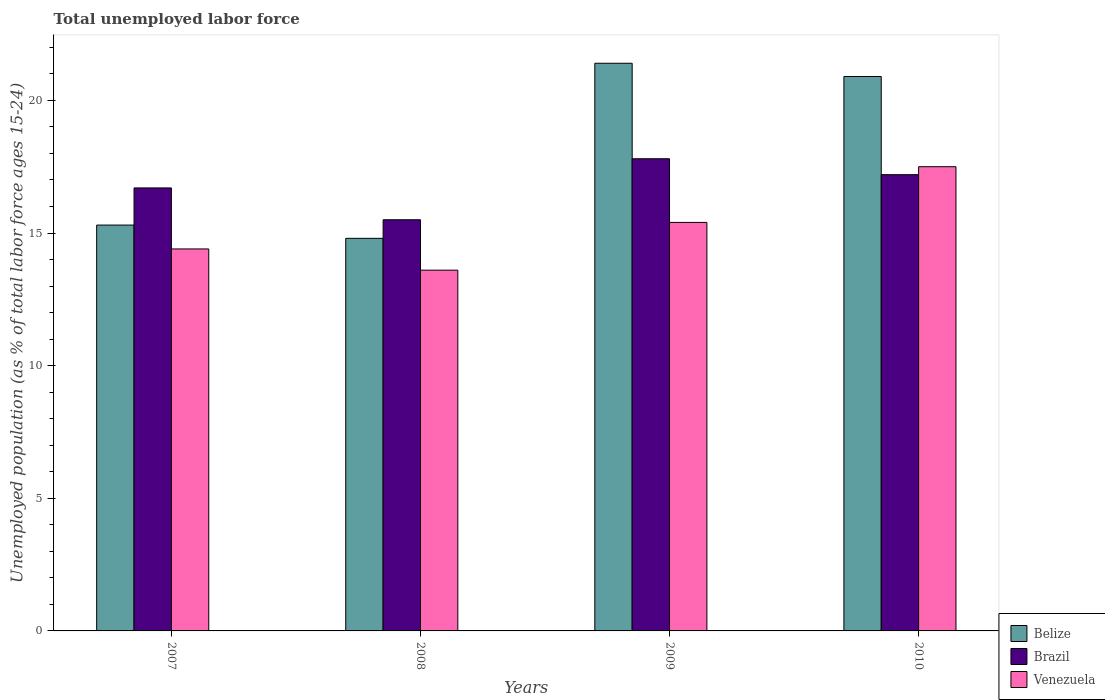How many different coloured bars are there?
Offer a very short reply. 3. How many groups of bars are there?
Give a very brief answer. 4. Are the number of bars on each tick of the X-axis equal?
Make the answer very short. Yes. How many bars are there on the 3rd tick from the right?
Your answer should be very brief. 3. In how many cases, is the number of bars for a given year not equal to the number of legend labels?
Your response must be concise. 0. What is the percentage of unemployed population in in Belize in 2008?
Your answer should be very brief. 14.8. Across all years, what is the maximum percentage of unemployed population in in Belize?
Give a very brief answer. 21.4. What is the total percentage of unemployed population in in Belize in the graph?
Make the answer very short. 72.4. What is the difference between the percentage of unemployed population in in Venezuela in 2007 and the percentage of unemployed population in in Belize in 2009?
Offer a very short reply. -7. What is the average percentage of unemployed population in in Belize per year?
Give a very brief answer. 18.1. In the year 2007, what is the difference between the percentage of unemployed population in in Brazil and percentage of unemployed population in in Venezuela?
Provide a succinct answer. 2.3. In how many years, is the percentage of unemployed population in in Venezuela greater than 14 %?
Offer a terse response. 3. What is the ratio of the percentage of unemployed population in in Venezuela in 2007 to that in 2009?
Keep it short and to the point. 0.94. What is the difference between the highest and the lowest percentage of unemployed population in in Belize?
Provide a succinct answer. 6.6. In how many years, is the percentage of unemployed population in in Brazil greater than the average percentage of unemployed population in in Brazil taken over all years?
Offer a very short reply. 2. What does the 1st bar from the left in 2010 represents?
Offer a terse response. Belize. Is it the case that in every year, the sum of the percentage of unemployed population in in Belize and percentage of unemployed population in in Venezuela is greater than the percentage of unemployed population in in Brazil?
Ensure brevity in your answer.  Yes. What is the difference between two consecutive major ticks on the Y-axis?
Ensure brevity in your answer.  5. Are the values on the major ticks of Y-axis written in scientific E-notation?
Offer a terse response. No. Does the graph contain any zero values?
Ensure brevity in your answer.  No. Where does the legend appear in the graph?
Make the answer very short. Bottom right. What is the title of the graph?
Your answer should be compact. Total unemployed labor force. What is the label or title of the X-axis?
Your response must be concise. Years. What is the label or title of the Y-axis?
Ensure brevity in your answer.  Unemployed population (as % of total labor force ages 15-24). What is the Unemployed population (as % of total labor force ages 15-24) in Belize in 2007?
Ensure brevity in your answer.  15.3. What is the Unemployed population (as % of total labor force ages 15-24) of Brazil in 2007?
Your answer should be compact. 16.7. What is the Unemployed population (as % of total labor force ages 15-24) in Venezuela in 2007?
Offer a terse response. 14.4. What is the Unemployed population (as % of total labor force ages 15-24) of Belize in 2008?
Give a very brief answer. 14.8. What is the Unemployed population (as % of total labor force ages 15-24) in Brazil in 2008?
Offer a terse response. 15.5. What is the Unemployed population (as % of total labor force ages 15-24) of Venezuela in 2008?
Ensure brevity in your answer.  13.6. What is the Unemployed population (as % of total labor force ages 15-24) in Belize in 2009?
Your answer should be compact. 21.4. What is the Unemployed population (as % of total labor force ages 15-24) of Brazil in 2009?
Give a very brief answer. 17.8. What is the Unemployed population (as % of total labor force ages 15-24) of Venezuela in 2009?
Give a very brief answer. 15.4. What is the Unemployed population (as % of total labor force ages 15-24) in Belize in 2010?
Your answer should be compact. 20.9. What is the Unemployed population (as % of total labor force ages 15-24) in Brazil in 2010?
Make the answer very short. 17.2. Across all years, what is the maximum Unemployed population (as % of total labor force ages 15-24) in Belize?
Your answer should be compact. 21.4. Across all years, what is the maximum Unemployed population (as % of total labor force ages 15-24) in Brazil?
Offer a terse response. 17.8. Across all years, what is the maximum Unemployed population (as % of total labor force ages 15-24) in Venezuela?
Offer a terse response. 17.5. Across all years, what is the minimum Unemployed population (as % of total labor force ages 15-24) in Belize?
Your response must be concise. 14.8. Across all years, what is the minimum Unemployed population (as % of total labor force ages 15-24) in Venezuela?
Offer a terse response. 13.6. What is the total Unemployed population (as % of total labor force ages 15-24) of Belize in the graph?
Ensure brevity in your answer.  72.4. What is the total Unemployed population (as % of total labor force ages 15-24) in Brazil in the graph?
Your response must be concise. 67.2. What is the total Unemployed population (as % of total labor force ages 15-24) in Venezuela in the graph?
Provide a short and direct response. 60.9. What is the difference between the Unemployed population (as % of total labor force ages 15-24) of Belize in 2007 and that in 2008?
Make the answer very short. 0.5. What is the difference between the Unemployed population (as % of total labor force ages 15-24) in Brazil in 2007 and that in 2008?
Offer a very short reply. 1.2. What is the difference between the Unemployed population (as % of total labor force ages 15-24) of Venezuela in 2007 and that in 2008?
Provide a short and direct response. 0.8. What is the difference between the Unemployed population (as % of total labor force ages 15-24) in Brazil in 2007 and that in 2009?
Make the answer very short. -1.1. What is the difference between the Unemployed population (as % of total labor force ages 15-24) of Brazil in 2007 and that in 2010?
Provide a succinct answer. -0.5. What is the difference between the Unemployed population (as % of total labor force ages 15-24) in Venezuela in 2008 and that in 2009?
Provide a succinct answer. -1.8. What is the difference between the Unemployed population (as % of total labor force ages 15-24) in Belize in 2009 and that in 2010?
Your response must be concise. 0.5. What is the difference between the Unemployed population (as % of total labor force ages 15-24) in Brazil in 2009 and that in 2010?
Keep it short and to the point. 0.6. What is the difference between the Unemployed population (as % of total labor force ages 15-24) of Brazil in 2007 and the Unemployed population (as % of total labor force ages 15-24) of Venezuela in 2008?
Your answer should be compact. 3.1. What is the difference between the Unemployed population (as % of total labor force ages 15-24) in Belize in 2007 and the Unemployed population (as % of total labor force ages 15-24) in Brazil in 2009?
Your answer should be compact. -2.5. What is the difference between the Unemployed population (as % of total labor force ages 15-24) in Belize in 2007 and the Unemployed population (as % of total labor force ages 15-24) in Venezuela in 2009?
Give a very brief answer. -0.1. What is the difference between the Unemployed population (as % of total labor force ages 15-24) of Brazil in 2007 and the Unemployed population (as % of total labor force ages 15-24) of Venezuela in 2009?
Make the answer very short. 1.3. What is the difference between the Unemployed population (as % of total labor force ages 15-24) in Belize in 2007 and the Unemployed population (as % of total labor force ages 15-24) in Brazil in 2010?
Your answer should be compact. -1.9. What is the difference between the Unemployed population (as % of total labor force ages 15-24) of Belize in 2007 and the Unemployed population (as % of total labor force ages 15-24) of Venezuela in 2010?
Your response must be concise. -2.2. What is the difference between the Unemployed population (as % of total labor force ages 15-24) of Belize in 2008 and the Unemployed population (as % of total labor force ages 15-24) of Brazil in 2009?
Keep it short and to the point. -3. What is the difference between the Unemployed population (as % of total labor force ages 15-24) in Belize in 2008 and the Unemployed population (as % of total labor force ages 15-24) in Venezuela in 2009?
Keep it short and to the point. -0.6. What is the difference between the Unemployed population (as % of total labor force ages 15-24) in Brazil in 2008 and the Unemployed population (as % of total labor force ages 15-24) in Venezuela in 2009?
Your answer should be very brief. 0.1. What is the difference between the Unemployed population (as % of total labor force ages 15-24) in Belize in 2008 and the Unemployed population (as % of total labor force ages 15-24) in Brazil in 2010?
Keep it short and to the point. -2.4. What is the difference between the Unemployed population (as % of total labor force ages 15-24) of Brazil in 2008 and the Unemployed population (as % of total labor force ages 15-24) of Venezuela in 2010?
Ensure brevity in your answer.  -2. What is the difference between the Unemployed population (as % of total labor force ages 15-24) of Belize in 2009 and the Unemployed population (as % of total labor force ages 15-24) of Brazil in 2010?
Provide a succinct answer. 4.2. What is the difference between the Unemployed population (as % of total labor force ages 15-24) in Belize in 2009 and the Unemployed population (as % of total labor force ages 15-24) in Venezuela in 2010?
Give a very brief answer. 3.9. What is the average Unemployed population (as % of total labor force ages 15-24) of Brazil per year?
Give a very brief answer. 16.8. What is the average Unemployed population (as % of total labor force ages 15-24) of Venezuela per year?
Provide a short and direct response. 15.22. In the year 2008, what is the difference between the Unemployed population (as % of total labor force ages 15-24) of Belize and Unemployed population (as % of total labor force ages 15-24) of Venezuela?
Your response must be concise. 1.2. In the year 2008, what is the difference between the Unemployed population (as % of total labor force ages 15-24) in Brazil and Unemployed population (as % of total labor force ages 15-24) in Venezuela?
Make the answer very short. 1.9. In the year 2009, what is the difference between the Unemployed population (as % of total labor force ages 15-24) in Belize and Unemployed population (as % of total labor force ages 15-24) in Brazil?
Provide a short and direct response. 3.6. In the year 2009, what is the difference between the Unemployed population (as % of total labor force ages 15-24) in Belize and Unemployed population (as % of total labor force ages 15-24) in Venezuela?
Your answer should be compact. 6. In the year 2009, what is the difference between the Unemployed population (as % of total labor force ages 15-24) in Brazil and Unemployed population (as % of total labor force ages 15-24) in Venezuela?
Provide a short and direct response. 2.4. In the year 2010, what is the difference between the Unemployed population (as % of total labor force ages 15-24) in Belize and Unemployed population (as % of total labor force ages 15-24) in Brazil?
Ensure brevity in your answer.  3.7. In the year 2010, what is the difference between the Unemployed population (as % of total labor force ages 15-24) of Brazil and Unemployed population (as % of total labor force ages 15-24) of Venezuela?
Your response must be concise. -0.3. What is the ratio of the Unemployed population (as % of total labor force ages 15-24) in Belize in 2007 to that in 2008?
Provide a succinct answer. 1.03. What is the ratio of the Unemployed population (as % of total labor force ages 15-24) in Brazil in 2007 to that in 2008?
Offer a very short reply. 1.08. What is the ratio of the Unemployed population (as % of total labor force ages 15-24) of Venezuela in 2007 to that in 2008?
Provide a short and direct response. 1.06. What is the ratio of the Unemployed population (as % of total labor force ages 15-24) of Belize in 2007 to that in 2009?
Give a very brief answer. 0.71. What is the ratio of the Unemployed population (as % of total labor force ages 15-24) of Brazil in 2007 to that in 2009?
Ensure brevity in your answer.  0.94. What is the ratio of the Unemployed population (as % of total labor force ages 15-24) in Venezuela in 2007 to that in 2009?
Keep it short and to the point. 0.94. What is the ratio of the Unemployed population (as % of total labor force ages 15-24) of Belize in 2007 to that in 2010?
Provide a succinct answer. 0.73. What is the ratio of the Unemployed population (as % of total labor force ages 15-24) of Brazil in 2007 to that in 2010?
Your answer should be compact. 0.97. What is the ratio of the Unemployed population (as % of total labor force ages 15-24) of Venezuela in 2007 to that in 2010?
Provide a succinct answer. 0.82. What is the ratio of the Unemployed population (as % of total labor force ages 15-24) of Belize in 2008 to that in 2009?
Your answer should be compact. 0.69. What is the ratio of the Unemployed population (as % of total labor force ages 15-24) of Brazil in 2008 to that in 2009?
Offer a terse response. 0.87. What is the ratio of the Unemployed population (as % of total labor force ages 15-24) of Venezuela in 2008 to that in 2009?
Ensure brevity in your answer.  0.88. What is the ratio of the Unemployed population (as % of total labor force ages 15-24) in Belize in 2008 to that in 2010?
Offer a terse response. 0.71. What is the ratio of the Unemployed population (as % of total labor force ages 15-24) in Brazil in 2008 to that in 2010?
Ensure brevity in your answer.  0.9. What is the ratio of the Unemployed population (as % of total labor force ages 15-24) of Venezuela in 2008 to that in 2010?
Your answer should be compact. 0.78. What is the ratio of the Unemployed population (as % of total labor force ages 15-24) of Belize in 2009 to that in 2010?
Offer a very short reply. 1.02. What is the ratio of the Unemployed population (as % of total labor force ages 15-24) in Brazil in 2009 to that in 2010?
Ensure brevity in your answer.  1.03. What is the ratio of the Unemployed population (as % of total labor force ages 15-24) in Venezuela in 2009 to that in 2010?
Keep it short and to the point. 0.88. What is the difference between the highest and the second highest Unemployed population (as % of total labor force ages 15-24) of Brazil?
Your answer should be very brief. 0.6. What is the difference between the highest and the lowest Unemployed population (as % of total labor force ages 15-24) of Venezuela?
Ensure brevity in your answer.  3.9. 